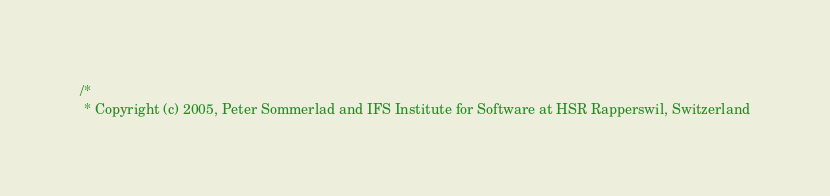<code> <loc_0><loc_0><loc_500><loc_500><_C++_>/*
 * Copyright (c) 2005, Peter Sommerlad and IFS Institute for Software at HSR Rapperswil, Switzerland</code> 